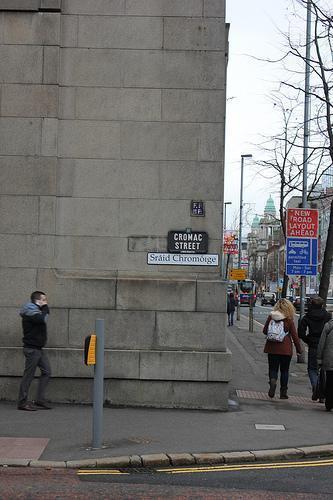How many people are carrying a white backpack?
Give a very brief answer. 1. 